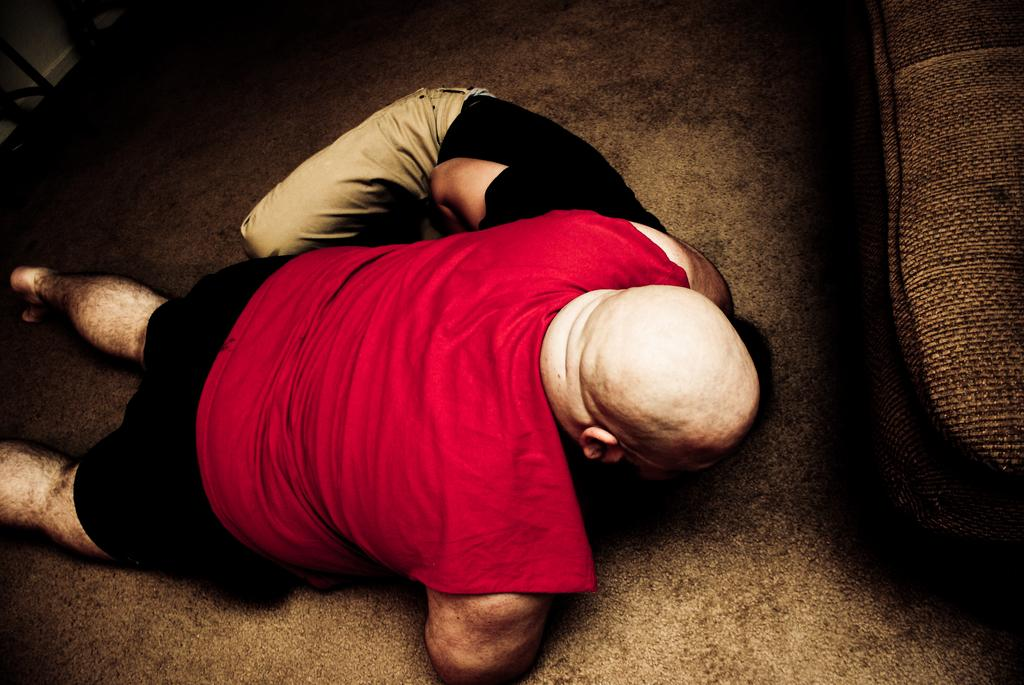What are the two persons in the image doing? They appear to be fighting in the middle of the image. Can you describe the location of the couch in the image? The couch is on the right side of the image. What type of dinner is being served on the couch in the image? There is no dinner or food visible in the image, and the couch is not being used for serving dinner. 